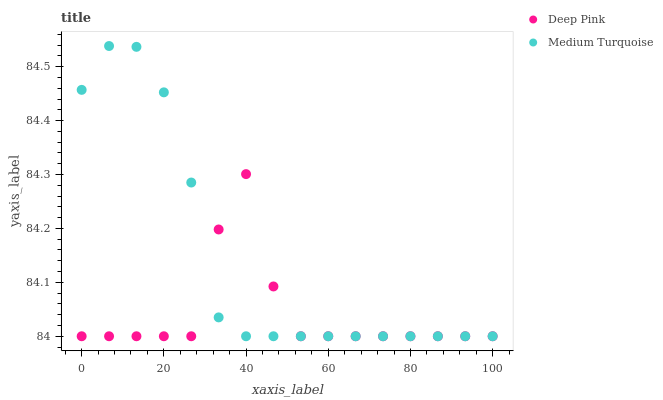Does Deep Pink have the minimum area under the curve?
Answer yes or no. Yes. Does Medium Turquoise have the maximum area under the curve?
Answer yes or no. Yes. Does Medium Turquoise have the minimum area under the curve?
Answer yes or no. No. Is Medium Turquoise the smoothest?
Answer yes or no. Yes. Is Deep Pink the roughest?
Answer yes or no. Yes. Is Medium Turquoise the roughest?
Answer yes or no. No. Does Deep Pink have the lowest value?
Answer yes or no. Yes. Does Medium Turquoise have the highest value?
Answer yes or no. Yes. Does Deep Pink intersect Medium Turquoise?
Answer yes or no. Yes. Is Deep Pink less than Medium Turquoise?
Answer yes or no. No. Is Deep Pink greater than Medium Turquoise?
Answer yes or no. No. 